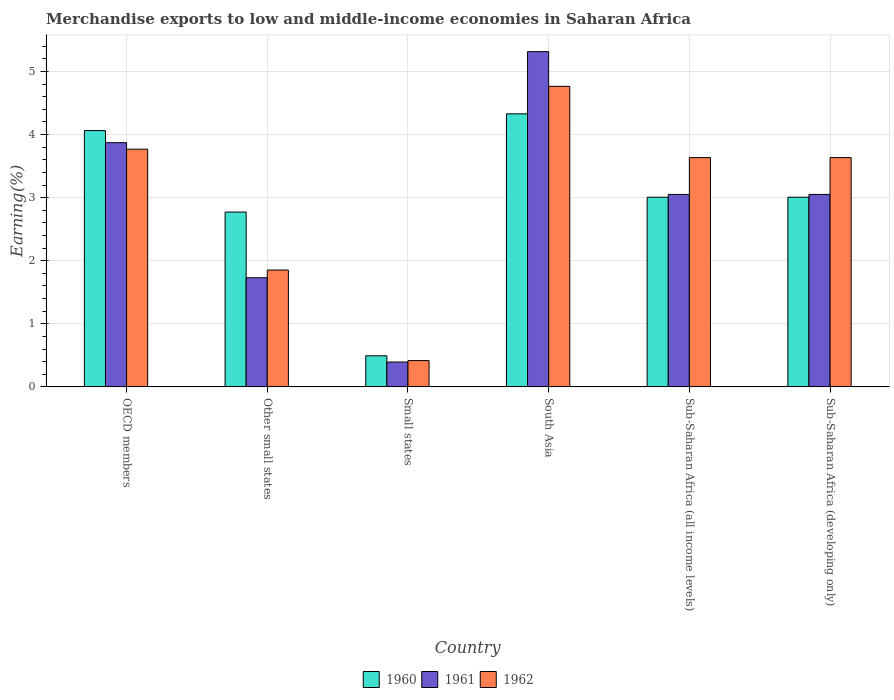How many different coloured bars are there?
Make the answer very short. 3. Are the number of bars per tick equal to the number of legend labels?
Offer a terse response. Yes. Are the number of bars on each tick of the X-axis equal?
Keep it short and to the point. Yes. How many bars are there on the 4th tick from the right?
Keep it short and to the point. 3. What is the label of the 3rd group of bars from the left?
Offer a terse response. Small states. What is the percentage of amount earned from merchandise exports in 1962 in Small states?
Provide a succinct answer. 0.42. Across all countries, what is the maximum percentage of amount earned from merchandise exports in 1960?
Make the answer very short. 4.33. Across all countries, what is the minimum percentage of amount earned from merchandise exports in 1961?
Keep it short and to the point. 0.39. In which country was the percentage of amount earned from merchandise exports in 1960 minimum?
Ensure brevity in your answer.  Small states. What is the total percentage of amount earned from merchandise exports in 1962 in the graph?
Keep it short and to the point. 18.07. What is the difference between the percentage of amount earned from merchandise exports in 1960 in Small states and that in Sub-Saharan Africa (developing only)?
Provide a short and direct response. -2.51. What is the difference between the percentage of amount earned from merchandise exports in 1961 in Sub-Saharan Africa (developing only) and the percentage of amount earned from merchandise exports in 1962 in South Asia?
Your answer should be very brief. -1.71. What is the average percentage of amount earned from merchandise exports in 1961 per country?
Offer a very short reply. 2.9. What is the difference between the percentage of amount earned from merchandise exports of/in 1961 and percentage of amount earned from merchandise exports of/in 1960 in Sub-Saharan Africa (developing only)?
Keep it short and to the point. 0.04. In how many countries, is the percentage of amount earned from merchandise exports in 1961 greater than 4.8 %?
Give a very brief answer. 1. What is the ratio of the percentage of amount earned from merchandise exports in 1960 in OECD members to that in Sub-Saharan Africa (all income levels)?
Your response must be concise. 1.35. What is the difference between the highest and the second highest percentage of amount earned from merchandise exports in 1961?
Offer a very short reply. -0.82. What is the difference between the highest and the lowest percentage of amount earned from merchandise exports in 1962?
Your answer should be very brief. 4.35. In how many countries, is the percentage of amount earned from merchandise exports in 1960 greater than the average percentage of amount earned from merchandise exports in 1960 taken over all countries?
Your response must be concise. 4. What does the 1st bar from the left in Sub-Saharan Africa (all income levels) represents?
Provide a short and direct response. 1960. Is it the case that in every country, the sum of the percentage of amount earned from merchandise exports in 1962 and percentage of amount earned from merchandise exports in 1960 is greater than the percentage of amount earned from merchandise exports in 1961?
Your answer should be very brief. Yes. How many bars are there?
Your answer should be compact. 18. Does the graph contain grids?
Offer a terse response. Yes. How many legend labels are there?
Your response must be concise. 3. How are the legend labels stacked?
Ensure brevity in your answer.  Horizontal. What is the title of the graph?
Provide a succinct answer. Merchandise exports to low and middle-income economies in Saharan Africa. Does "1996" appear as one of the legend labels in the graph?
Provide a succinct answer. No. What is the label or title of the Y-axis?
Keep it short and to the point. Earning(%). What is the Earning(%) of 1960 in OECD members?
Your answer should be compact. 4.06. What is the Earning(%) in 1961 in OECD members?
Your answer should be very brief. 3.87. What is the Earning(%) in 1962 in OECD members?
Keep it short and to the point. 3.77. What is the Earning(%) of 1960 in Other small states?
Your response must be concise. 2.77. What is the Earning(%) in 1961 in Other small states?
Your response must be concise. 1.73. What is the Earning(%) of 1962 in Other small states?
Keep it short and to the point. 1.85. What is the Earning(%) of 1960 in Small states?
Offer a terse response. 0.49. What is the Earning(%) in 1961 in Small states?
Offer a very short reply. 0.39. What is the Earning(%) of 1962 in Small states?
Your response must be concise. 0.42. What is the Earning(%) in 1960 in South Asia?
Make the answer very short. 4.33. What is the Earning(%) in 1961 in South Asia?
Your response must be concise. 5.31. What is the Earning(%) of 1962 in South Asia?
Keep it short and to the point. 4.76. What is the Earning(%) of 1960 in Sub-Saharan Africa (all income levels)?
Offer a very short reply. 3.01. What is the Earning(%) of 1961 in Sub-Saharan Africa (all income levels)?
Provide a succinct answer. 3.05. What is the Earning(%) of 1962 in Sub-Saharan Africa (all income levels)?
Give a very brief answer. 3.63. What is the Earning(%) of 1960 in Sub-Saharan Africa (developing only)?
Keep it short and to the point. 3.01. What is the Earning(%) of 1961 in Sub-Saharan Africa (developing only)?
Give a very brief answer. 3.05. What is the Earning(%) of 1962 in Sub-Saharan Africa (developing only)?
Offer a very short reply. 3.63. Across all countries, what is the maximum Earning(%) in 1960?
Your answer should be very brief. 4.33. Across all countries, what is the maximum Earning(%) in 1961?
Provide a short and direct response. 5.31. Across all countries, what is the maximum Earning(%) in 1962?
Your response must be concise. 4.76. Across all countries, what is the minimum Earning(%) of 1960?
Ensure brevity in your answer.  0.49. Across all countries, what is the minimum Earning(%) in 1961?
Your answer should be very brief. 0.39. Across all countries, what is the minimum Earning(%) in 1962?
Your response must be concise. 0.42. What is the total Earning(%) of 1960 in the graph?
Provide a short and direct response. 17.67. What is the total Earning(%) of 1961 in the graph?
Keep it short and to the point. 17.41. What is the total Earning(%) in 1962 in the graph?
Ensure brevity in your answer.  18.07. What is the difference between the Earning(%) of 1960 in OECD members and that in Other small states?
Offer a terse response. 1.29. What is the difference between the Earning(%) in 1961 in OECD members and that in Other small states?
Your answer should be compact. 2.14. What is the difference between the Earning(%) of 1962 in OECD members and that in Other small states?
Your response must be concise. 1.92. What is the difference between the Earning(%) of 1960 in OECD members and that in Small states?
Make the answer very short. 3.57. What is the difference between the Earning(%) in 1961 in OECD members and that in Small states?
Provide a short and direct response. 3.48. What is the difference between the Earning(%) of 1962 in OECD members and that in Small states?
Offer a very short reply. 3.35. What is the difference between the Earning(%) of 1960 in OECD members and that in South Asia?
Your answer should be compact. -0.27. What is the difference between the Earning(%) of 1961 in OECD members and that in South Asia?
Provide a short and direct response. -1.44. What is the difference between the Earning(%) of 1962 in OECD members and that in South Asia?
Make the answer very short. -1. What is the difference between the Earning(%) in 1960 in OECD members and that in Sub-Saharan Africa (all income levels)?
Your response must be concise. 1.06. What is the difference between the Earning(%) of 1961 in OECD members and that in Sub-Saharan Africa (all income levels)?
Your answer should be very brief. 0.82. What is the difference between the Earning(%) in 1962 in OECD members and that in Sub-Saharan Africa (all income levels)?
Provide a succinct answer. 0.13. What is the difference between the Earning(%) of 1960 in OECD members and that in Sub-Saharan Africa (developing only)?
Your answer should be very brief. 1.06. What is the difference between the Earning(%) in 1961 in OECD members and that in Sub-Saharan Africa (developing only)?
Offer a very short reply. 0.82. What is the difference between the Earning(%) of 1962 in OECD members and that in Sub-Saharan Africa (developing only)?
Your answer should be very brief. 0.13. What is the difference between the Earning(%) in 1960 in Other small states and that in Small states?
Keep it short and to the point. 2.28. What is the difference between the Earning(%) in 1961 in Other small states and that in Small states?
Offer a very short reply. 1.34. What is the difference between the Earning(%) of 1962 in Other small states and that in Small states?
Your answer should be very brief. 1.44. What is the difference between the Earning(%) in 1960 in Other small states and that in South Asia?
Make the answer very short. -1.56. What is the difference between the Earning(%) in 1961 in Other small states and that in South Asia?
Your response must be concise. -3.58. What is the difference between the Earning(%) of 1962 in Other small states and that in South Asia?
Your response must be concise. -2.91. What is the difference between the Earning(%) in 1960 in Other small states and that in Sub-Saharan Africa (all income levels)?
Give a very brief answer. -0.24. What is the difference between the Earning(%) of 1961 in Other small states and that in Sub-Saharan Africa (all income levels)?
Give a very brief answer. -1.32. What is the difference between the Earning(%) of 1962 in Other small states and that in Sub-Saharan Africa (all income levels)?
Make the answer very short. -1.78. What is the difference between the Earning(%) in 1960 in Other small states and that in Sub-Saharan Africa (developing only)?
Your response must be concise. -0.24. What is the difference between the Earning(%) in 1961 in Other small states and that in Sub-Saharan Africa (developing only)?
Your response must be concise. -1.32. What is the difference between the Earning(%) of 1962 in Other small states and that in Sub-Saharan Africa (developing only)?
Your response must be concise. -1.78. What is the difference between the Earning(%) of 1960 in Small states and that in South Asia?
Your answer should be compact. -3.84. What is the difference between the Earning(%) in 1961 in Small states and that in South Asia?
Your response must be concise. -4.92. What is the difference between the Earning(%) in 1962 in Small states and that in South Asia?
Offer a very short reply. -4.35. What is the difference between the Earning(%) in 1960 in Small states and that in Sub-Saharan Africa (all income levels)?
Keep it short and to the point. -2.51. What is the difference between the Earning(%) of 1961 in Small states and that in Sub-Saharan Africa (all income levels)?
Your response must be concise. -2.66. What is the difference between the Earning(%) of 1962 in Small states and that in Sub-Saharan Africa (all income levels)?
Keep it short and to the point. -3.22. What is the difference between the Earning(%) of 1960 in Small states and that in Sub-Saharan Africa (developing only)?
Offer a very short reply. -2.51. What is the difference between the Earning(%) of 1961 in Small states and that in Sub-Saharan Africa (developing only)?
Ensure brevity in your answer.  -2.66. What is the difference between the Earning(%) in 1962 in Small states and that in Sub-Saharan Africa (developing only)?
Provide a short and direct response. -3.22. What is the difference between the Earning(%) of 1960 in South Asia and that in Sub-Saharan Africa (all income levels)?
Give a very brief answer. 1.32. What is the difference between the Earning(%) of 1961 in South Asia and that in Sub-Saharan Africa (all income levels)?
Offer a terse response. 2.26. What is the difference between the Earning(%) in 1962 in South Asia and that in Sub-Saharan Africa (all income levels)?
Keep it short and to the point. 1.13. What is the difference between the Earning(%) of 1960 in South Asia and that in Sub-Saharan Africa (developing only)?
Offer a very short reply. 1.32. What is the difference between the Earning(%) in 1961 in South Asia and that in Sub-Saharan Africa (developing only)?
Offer a very short reply. 2.26. What is the difference between the Earning(%) of 1962 in South Asia and that in Sub-Saharan Africa (developing only)?
Keep it short and to the point. 1.13. What is the difference between the Earning(%) in 1960 in Sub-Saharan Africa (all income levels) and that in Sub-Saharan Africa (developing only)?
Make the answer very short. 0. What is the difference between the Earning(%) in 1961 in Sub-Saharan Africa (all income levels) and that in Sub-Saharan Africa (developing only)?
Ensure brevity in your answer.  0. What is the difference between the Earning(%) of 1962 in Sub-Saharan Africa (all income levels) and that in Sub-Saharan Africa (developing only)?
Ensure brevity in your answer.  0. What is the difference between the Earning(%) in 1960 in OECD members and the Earning(%) in 1961 in Other small states?
Your response must be concise. 2.33. What is the difference between the Earning(%) in 1960 in OECD members and the Earning(%) in 1962 in Other small states?
Your answer should be compact. 2.21. What is the difference between the Earning(%) of 1961 in OECD members and the Earning(%) of 1962 in Other small states?
Give a very brief answer. 2.02. What is the difference between the Earning(%) in 1960 in OECD members and the Earning(%) in 1961 in Small states?
Provide a succinct answer. 3.67. What is the difference between the Earning(%) in 1960 in OECD members and the Earning(%) in 1962 in Small states?
Your response must be concise. 3.65. What is the difference between the Earning(%) of 1961 in OECD members and the Earning(%) of 1962 in Small states?
Your answer should be compact. 3.45. What is the difference between the Earning(%) in 1960 in OECD members and the Earning(%) in 1961 in South Asia?
Give a very brief answer. -1.25. What is the difference between the Earning(%) in 1960 in OECD members and the Earning(%) in 1962 in South Asia?
Ensure brevity in your answer.  -0.7. What is the difference between the Earning(%) of 1961 in OECD members and the Earning(%) of 1962 in South Asia?
Your answer should be compact. -0.89. What is the difference between the Earning(%) in 1960 in OECD members and the Earning(%) in 1961 in Sub-Saharan Africa (all income levels)?
Keep it short and to the point. 1.01. What is the difference between the Earning(%) of 1960 in OECD members and the Earning(%) of 1962 in Sub-Saharan Africa (all income levels)?
Give a very brief answer. 0.43. What is the difference between the Earning(%) in 1961 in OECD members and the Earning(%) in 1962 in Sub-Saharan Africa (all income levels)?
Provide a succinct answer. 0.24. What is the difference between the Earning(%) in 1960 in OECD members and the Earning(%) in 1961 in Sub-Saharan Africa (developing only)?
Give a very brief answer. 1.01. What is the difference between the Earning(%) in 1960 in OECD members and the Earning(%) in 1962 in Sub-Saharan Africa (developing only)?
Your response must be concise. 0.43. What is the difference between the Earning(%) in 1961 in OECD members and the Earning(%) in 1962 in Sub-Saharan Africa (developing only)?
Ensure brevity in your answer.  0.24. What is the difference between the Earning(%) in 1960 in Other small states and the Earning(%) in 1961 in Small states?
Offer a very short reply. 2.38. What is the difference between the Earning(%) of 1960 in Other small states and the Earning(%) of 1962 in Small states?
Keep it short and to the point. 2.35. What is the difference between the Earning(%) of 1961 in Other small states and the Earning(%) of 1962 in Small states?
Your answer should be compact. 1.31. What is the difference between the Earning(%) in 1960 in Other small states and the Earning(%) in 1961 in South Asia?
Make the answer very short. -2.54. What is the difference between the Earning(%) of 1960 in Other small states and the Earning(%) of 1962 in South Asia?
Your answer should be very brief. -1.99. What is the difference between the Earning(%) of 1961 in Other small states and the Earning(%) of 1962 in South Asia?
Provide a short and direct response. -3.03. What is the difference between the Earning(%) in 1960 in Other small states and the Earning(%) in 1961 in Sub-Saharan Africa (all income levels)?
Your response must be concise. -0.28. What is the difference between the Earning(%) of 1960 in Other small states and the Earning(%) of 1962 in Sub-Saharan Africa (all income levels)?
Keep it short and to the point. -0.86. What is the difference between the Earning(%) in 1961 in Other small states and the Earning(%) in 1962 in Sub-Saharan Africa (all income levels)?
Give a very brief answer. -1.9. What is the difference between the Earning(%) of 1960 in Other small states and the Earning(%) of 1961 in Sub-Saharan Africa (developing only)?
Give a very brief answer. -0.28. What is the difference between the Earning(%) in 1960 in Other small states and the Earning(%) in 1962 in Sub-Saharan Africa (developing only)?
Offer a terse response. -0.86. What is the difference between the Earning(%) of 1961 in Other small states and the Earning(%) of 1962 in Sub-Saharan Africa (developing only)?
Your answer should be very brief. -1.9. What is the difference between the Earning(%) in 1960 in Small states and the Earning(%) in 1961 in South Asia?
Offer a very short reply. -4.82. What is the difference between the Earning(%) of 1960 in Small states and the Earning(%) of 1962 in South Asia?
Your response must be concise. -4.27. What is the difference between the Earning(%) in 1961 in Small states and the Earning(%) in 1962 in South Asia?
Provide a short and direct response. -4.37. What is the difference between the Earning(%) in 1960 in Small states and the Earning(%) in 1961 in Sub-Saharan Africa (all income levels)?
Your response must be concise. -2.56. What is the difference between the Earning(%) of 1960 in Small states and the Earning(%) of 1962 in Sub-Saharan Africa (all income levels)?
Your answer should be compact. -3.14. What is the difference between the Earning(%) in 1961 in Small states and the Earning(%) in 1962 in Sub-Saharan Africa (all income levels)?
Your answer should be very brief. -3.24. What is the difference between the Earning(%) in 1960 in Small states and the Earning(%) in 1961 in Sub-Saharan Africa (developing only)?
Offer a terse response. -2.56. What is the difference between the Earning(%) in 1960 in Small states and the Earning(%) in 1962 in Sub-Saharan Africa (developing only)?
Provide a short and direct response. -3.14. What is the difference between the Earning(%) of 1961 in Small states and the Earning(%) of 1962 in Sub-Saharan Africa (developing only)?
Your answer should be compact. -3.24. What is the difference between the Earning(%) of 1960 in South Asia and the Earning(%) of 1961 in Sub-Saharan Africa (all income levels)?
Provide a short and direct response. 1.28. What is the difference between the Earning(%) of 1960 in South Asia and the Earning(%) of 1962 in Sub-Saharan Africa (all income levels)?
Ensure brevity in your answer.  0.69. What is the difference between the Earning(%) of 1961 in South Asia and the Earning(%) of 1962 in Sub-Saharan Africa (all income levels)?
Your response must be concise. 1.68. What is the difference between the Earning(%) of 1960 in South Asia and the Earning(%) of 1961 in Sub-Saharan Africa (developing only)?
Provide a short and direct response. 1.28. What is the difference between the Earning(%) of 1960 in South Asia and the Earning(%) of 1962 in Sub-Saharan Africa (developing only)?
Ensure brevity in your answer.  0.69. What is the difference between the Earning(%) of 1961 in South Asia and the Earning(%) of 1962 in Sub-Saharan Africa (developing only)?
Give a very brief answer. 1.68. What is the difference between the Earning(%) in 1960 in Sub-Saharan Africa (all income levels) and the Earning(%) in 1961 in Sub-Saharan Africa (developing only)?
Your answer should be compact. -0.04. What is the difference between the Earning(%) of 1960 in Sub-Saharan Africa (all income levels) and the Earning(%) of 1962 in Sub-Saharan Africa (developing only)?
Keep it short and to the point. -0.63. What is the difference between the Earning(%) in 1961 in Sub-Saharan Africa (all income levels) and the Earning(%) in 1962 in Sub-Saharan Africa (developing only)?
Your response must be concise. -0.58. What is the average Earning(%) in 1960 per country?
Give a very brief answer. 2.94. What is the average Earning(%) of 1961 per country?
Offer a terse response. 2.9. What is the average Earning(%) of 1962 per country?
Provide a succinct answer. 3.01. What is the difference between the Earning(%) of 1960 and Earning(%) of 1961 in OECD members?
Offer a terse response. 0.19. What is the difference between the Earning(%) in 1960 and Earning(%) in 1962 in OECD members?
Your response must be concise. 0.3. What is the difference between the Earning(%) in 1961 and Earning(%) in 1962 in OECD members?
Provide a short and direct response. 0.1. What is the difference between the Earning(%) of 1960 and Earning(%) of 1961 in Other small states?
Offer a terse response. 1.04. What is the difference between the Earning(%) of 1960 and Earning(%) of 1962 in Other small states?
Your response must be concise. 0.92. What is the difference between the Earning(%) of 1961 and Earning(%) of 1962 in Other small states?
Your answer should be very brief. -0.12. What is the difference between the Earning(%) of 1960 and Earning(%) of 1961 in Small states?
Make the answer very short. 0.1. What is the difference between the Earning(%) of 1960 and Earning(%) of 1962 in Small states?
Provide a short and direct response. 0.08. What is the difference between the Earning(%) of 1961 and Earning(%) of 1962 in Small states?
Your answer should be compact. -0.02. What is the difference between the Earning(%) of 1960 and Earning(%) of 1961 in South Asia?
Offer a very short reply. -0.99. What is the difference between the Earning(%) in 1960 and Earning(%) in 1962 in South Asia?
Provide a succinct answer. -0.44. What is the difference between the Earning(%) in 1961 and Earning(%) in 1962 in South Asia?
Offer a very short reply. 0.55. What is the difference between the Earning(%) of 1960 and Earning(%) of 1961 in Sub-Saharan Africa (all income levels)?
Your answer should be very brief. -0.04. What is the difference between the Earning(%) in 1960 and Earning(%) in 1962 in Sub-Saharan Africa (all income levels)?
Your answer should be compact. -0.63. What is the difference between the Earning(%) of 1961 and Earning(%) of 1962 in Sub-Saharan Africa (all income levels)?
Keep it short and to the point. -0.58. What is the difference between the Earning(%) in 1960 and Earning(%) in 1961 in Sub-Saharan Africa (developing only)?
Offer a terse response. -0.04. What is the difference between the Earning(%) of 1960 and Earning(%) of 1962 in Sub-Saharan Africa (developing only)?
Your answer should be very brief. -0.63. What is the difference between the Earning(%) of 1961 and Earning(%) of 1962 in Sub-Saharan Africa (developing only)?
Your answer should be compact. -0.58. What is the ratio of the Earning(%) in 1960 in OECD members to that in Other small states?
Provide a short and direct response. 1.47. What is the ratio of the Earning(%) in 1961 in OECD members to that in Other small states?
Your answer should be very brief. 2.24. What is the ratio of the Earning(%) of 1962 in OECD members to that in Other small states?
Offer a terse response. 2.03. What is the ratio of the Earning(%) in 1960 in OECD members to that in Small states?
Provide a short and direct response. 8.25. What is the ratio of the Earning(%) in 1961 in OECD members to that in Small states?
Offer a terse response. 9.83. What is the ratio of the Earning(%) of 1962 in OECD members to that in Small states?
Offer a terse response. 9.04. What is the ratio of the Earning(%) in 1960 in OECD members to that in South Asia?
Ensure brevity in your answer.  0.94. What is the ratio of the Earning(%) in 1961 in OECD members to that in South Asia?
Offer a terse response. 0.73. What is the ratio of the Earning(%) in 1962 in OECD members to that in South Asia?
Give a very brief answer. 0.79. What is the ratio of the Earning(%) in 1960 in OECD members to that in Sub-Saharan Africa (all income levels)?
Provide a succinct answer. 1.35. What is the ratio of the Earning(%) of 1961 in OECD members to that in Sub-Saharan Africa (all income levels)?
Offer a very short reply. 1.27. What is the ratio of the Earning(%) of 1962 in OECD members to that in Sub-Saharan Africa (all income levels)?
Provide a succinct answer. 1.04. What is the ratio of the Earning(%) in 1960 in OECD members to that in Sub-Saharan Africa (developing only)?
Offer a very short reply. 1.35. What is the ratio of the Earning(%) of 1961 in OECD members to that in Sub-Saharan Africa (developing only)?
Your response must be concise. 1.27. What is the ratio of the Earning(%) of 1962 in OECD members to that in Sub-Saharan Africa (developing only)?
Offer a very short reply. 1.04. What is the ratio of the Earning(%) in 1960 in Other small states to that in Small states?
Provide a succinct answer. 5.62. What is the ratio of the Earning(%) in 1961 in Other small states to that in Small states?
Make the answer very short. 4.39. What is the ratio of the Earning(%) in 1962 in Other small states to that in Small states?
Provide a short and direct response. 4.44. What is the ratio of the Earning(%) in 1960 in Other small states to that in South Asia?
Ensure brevity in your answer.  0.64. What is the ratio of the Earning(%) in 1961 in Other small states to that in South Asia?
Provide a short and direct response. 0.33. What is the ratio of the Earning(%) of 1962 in Other small states to that in South Asia?
Ensure brevity in your answer.  0.39. What is the ratio of the Earning(%) of 1960 in Other small states to that in Sub-Saharan Africa (all income levels)?
Give a very brief answer. 0.92. What is the ratio of the Earning(%) in 1961 in Other small states to that in Sub-Saharan Africa (all income levels)?
Keep it short and to the point. 0.57. What is the ratio of the Earning(%) of 1962 in Other small states to that in Sub-Saharan Africa (all income levels)?
Provide a succinct answer. 0.51. What is the ratio of the Earning(%) in 1960 in Other small states to that in Sub-Saharan Africa (developing only)?
Give a very brief answer. 0.92. What is the ratio of the Earning(%) of 1961 in Other small states to that in Sub-Saharan Africa (developing only)?
Provide a short and direct response. 0.57. What is the ratio of the Earning(%) in 1962 in Other small states to that in Sub-Saharan Africa (developing only)?
Your response must be concise. 0.51. What is the ratio of the Earning(%) of 1960 in Small states to that in South Asia?
Keep it short and to the point. 0.11. What is the ratio of the Earning(%) of 1961 in Small states to that in South Asia?
Your answer should be very brief. 0.07. What is the ratio of the Earning(%) of 1962 in Small states to that in South Asia?
Offer a very short reply. 0.09. What is the ratio of the Earning(%) of 1960 in Small states to that in Sub-Saharan Africa (all income levels)?
Provide a short and direct response. 0.16. What is the ratio of the Earning(%) in 1961 in Small states to that in Sub-Saharan Africa (all income levels)?
Make the answer very short. 0.13. What is the ratio of the Earning(%) in 1962 in Small states to that in Sub-Saharan Africa (all income levels)?
Provide a succinct answer. 0.11. What is the ratio of the Earning(%) in 1960 in Small states to that in Sub-Saharan Africa (developing only)?
Ensure brevity in your answer.  0.16. What is the ratio of the Earning(%) in 1961 in Small states to that in Sub-Saharan Africa (developing only)?
Make the answer very short. 0.13. What is the ratio of the Earning(%) in 1962 in Small states to that in Sub-Saharan Africa (developing only)?
Provide a succinct answer. 0.11. What is the ratio of the Earning(%) in 1960 in South Asia to that in Sub-Saharan Africa (all income levels)?
Make the answer very short. 1.44. What is the ratio of the Earning(%) in 1961 in South Asia to that in Sub-Saharan Africa (all income levels)?
Give a very brief answer. 1.74. What is the ratio of the Earning(%) in 1962 in South Asia to that in Sub-Saharan Africa (all income levels)?
Your response must be concise. 1.31. What is the ratio of the Earning(%) in 1960 in South Asia to that in Sub-Saharan Africa (developing only)?
Make the answer very short. 1.44. What is the ratio of the Earning(%) in 1961 in South Asia to that in Sub-Saharan Africa (developing only)?
Give a very brief answer. 1.74. What is the ratio of the Earning(%) of 1962 in South Asia to that in Sub-Saharan Africa (developing only)?
Your answer should be very brief. 1.31. What is the ratio of the Earning(%) in 1960 in Sub-Saharan Africa (all income levels) to that in Sub-Saharan Africa (developing only)?
Provide a succinct answer. 1. What is the ratio of the Earning(%) in 1962 in Sub-Saharan Africa (all income levels) to that in Sub-Saharan Africa (developing only)?
Your answer should be very brief. 1. What is the difference between the highest and the second highest Earning(%) of 1960?
Your answer should be compact. 0.27. What is the difference between the highest and the second highest Earning(%) in 1961?
Your answer should be compact. 1.44. What is the difference between the highest and the lowest Earning(%) of 1960?
Provide a short and direct response. 3.84. What is the difference between the highest and the lowest Earning(%) of 1961?
Your answer should be compact. 4.92. What is the difference between the highest and the lowest Earning(%) of 1962?
Make the answer very short. 4.35. 